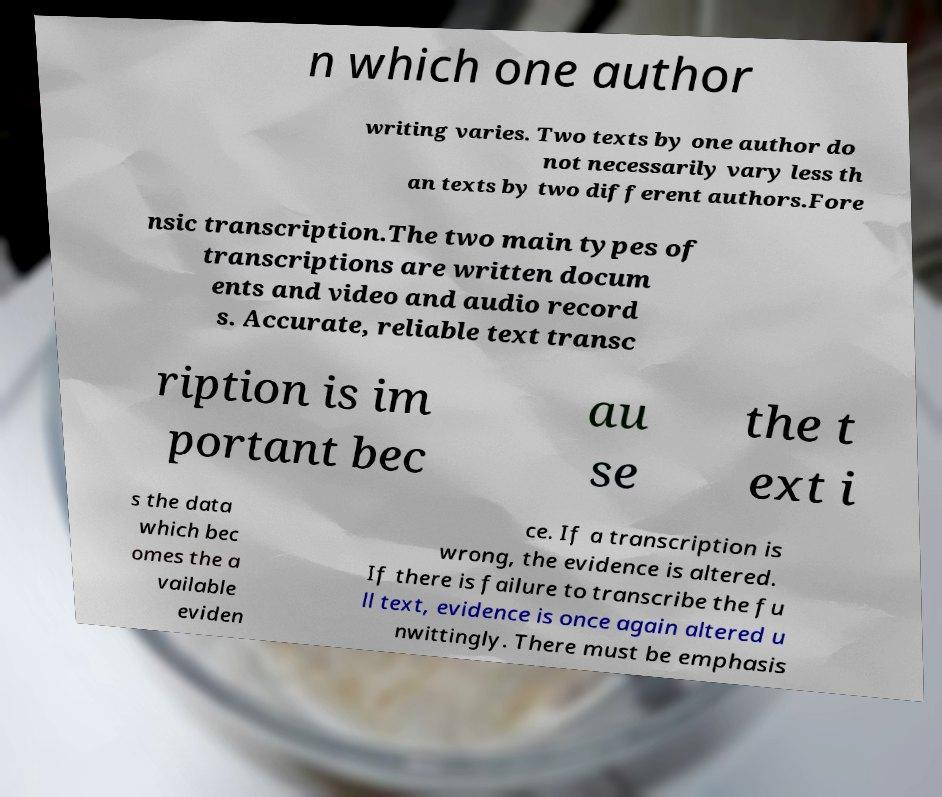What messages or text are displayed in this image? I need them in a readable, typed format. n which one author writing varies. Two texts by one author do not necessarily vary less th an texts by two different authors.Fore nsic transcription.The two main types of transcriptions are written docum ents and video and audio record s. Accurate, reliable text transc ription is im portant bec au se the t ext i s the data which bec omes the a vailable eviden ce. If a transcription is wrong, the evidence is altered. If there is failure to transcribe the fu ll text, evidence is once again altered u nwittingly. There must be emphasis 